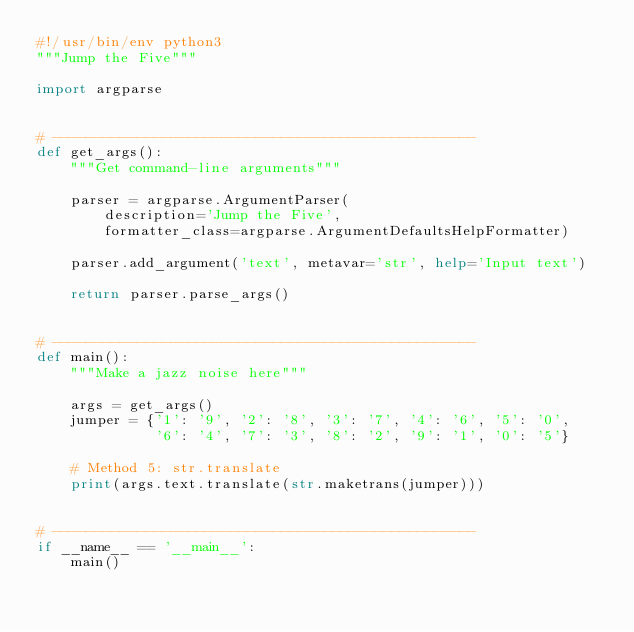Convert code to text. <code><loc_0><loc_0><loc_500><loc_500><_Python_>#!/usr/bin/env python3
"""Jump the Five"""

import argparse


# --------------------------------------------------
def get_args():
    """Get command-line arguments"""

    parser = argparse.ArgumentParser(
        description='Jump the Five',
        formatter_class=argparse.ArgumentDefaultsHelpFormatter)

    parser.add_argument('text', metavar='str', help='Input text')

    return parser.parse_args()


# --------------------------------------------------
def main():
    """Make a jazz noise here"""

    args = get_args()
    jumper = {'1': '9', '2': '8', '3': '7', '4': '6', '5': '0',
              '6': '4', '7': '3', '8': '2', '9': '1', '0': '5'}

    # Method 5: str.translate
    print(args.text.translate(str.maketrans(jumper)))


# --------------------------------------------------
if __name__ == '__main__':
    main()
</code> 